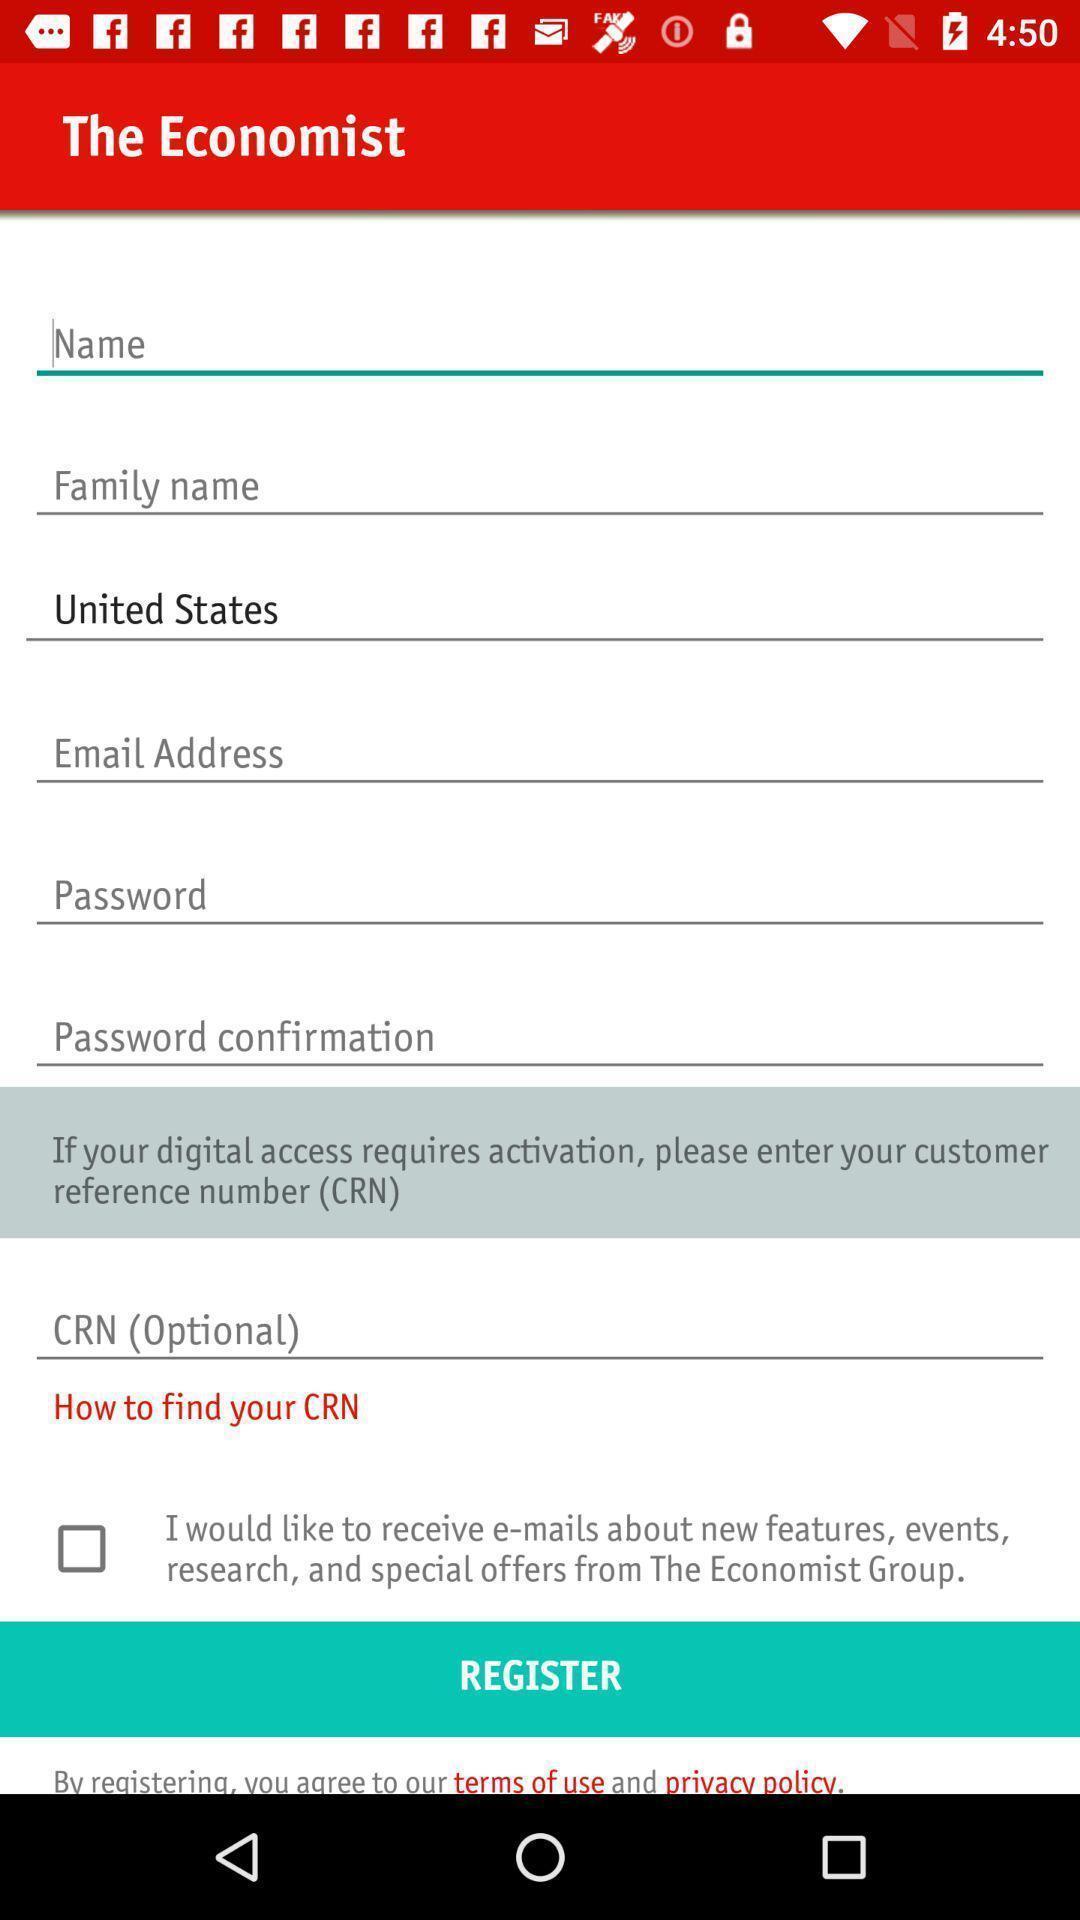Please provide a description for this image. Various details to be filled page displayed. 